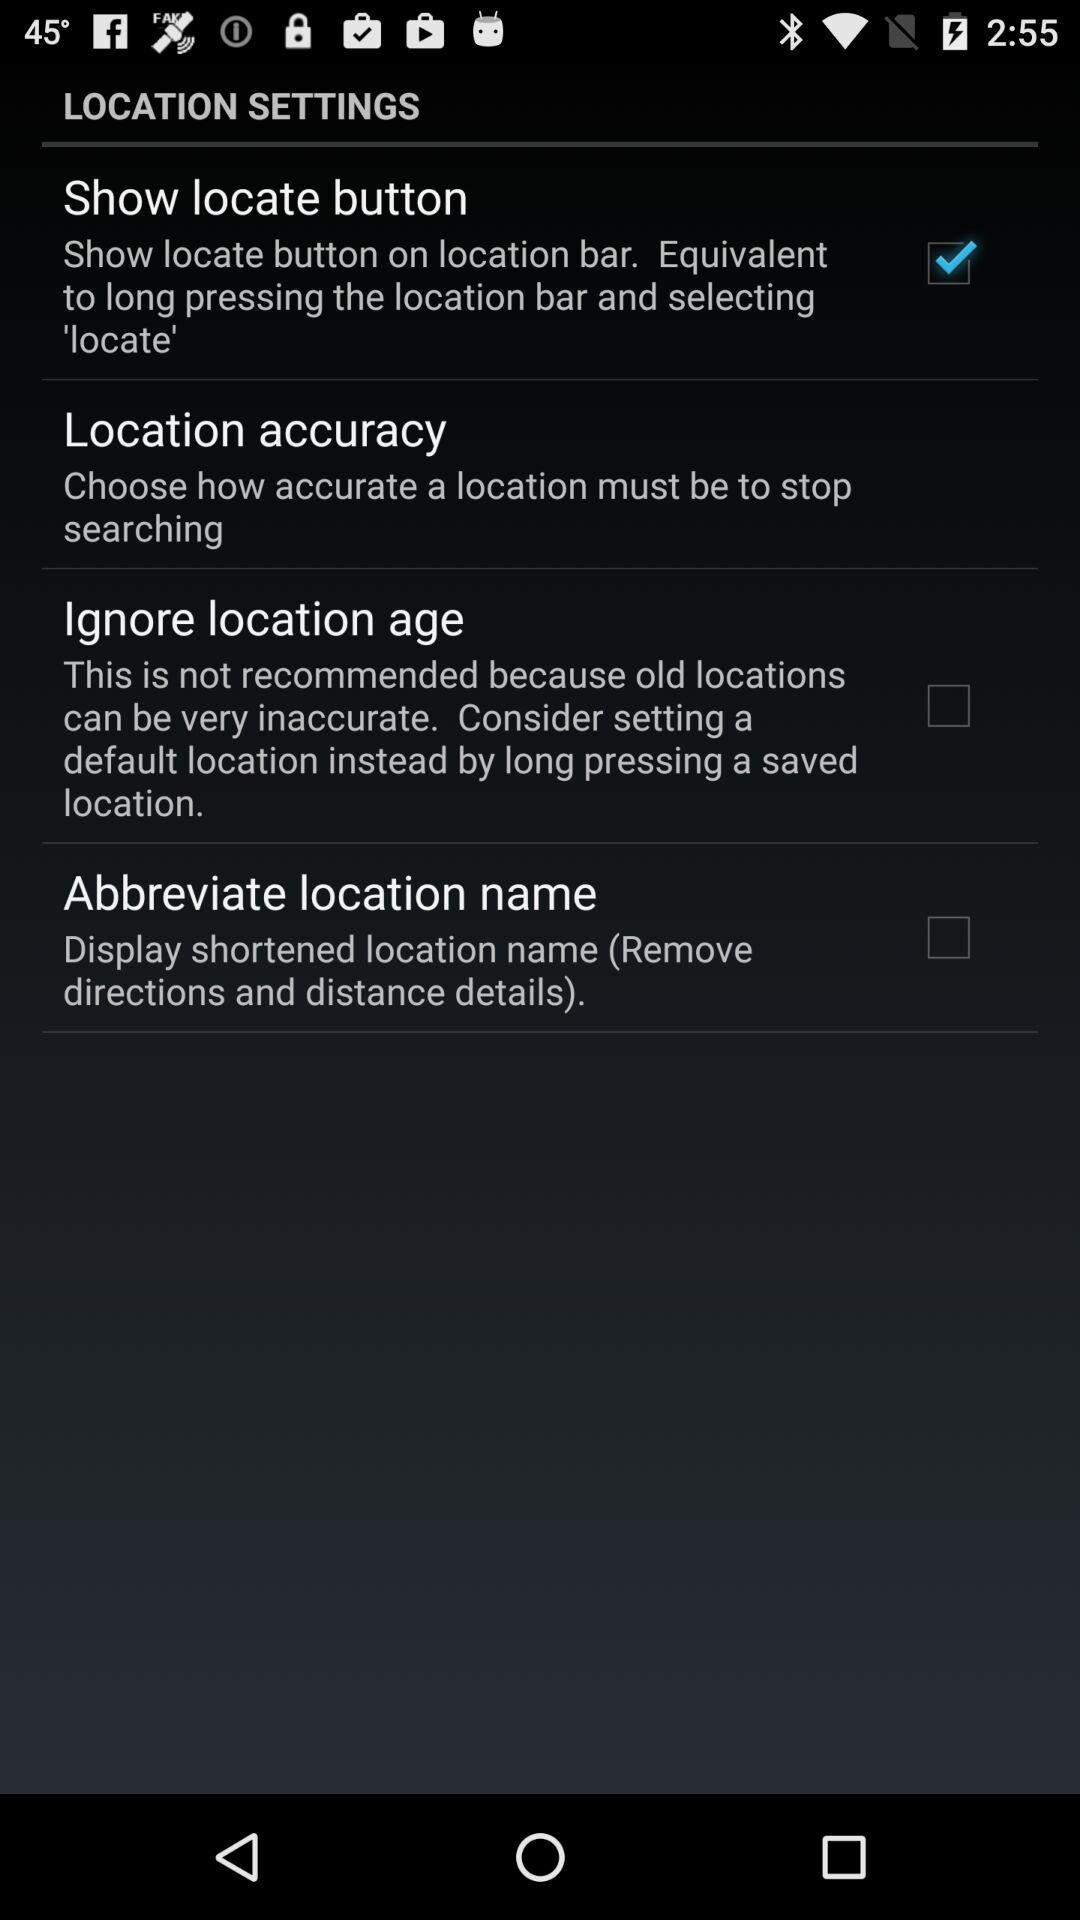How many check boxes are there in the location settings?
Answer the question using a single word or phrase. 3 